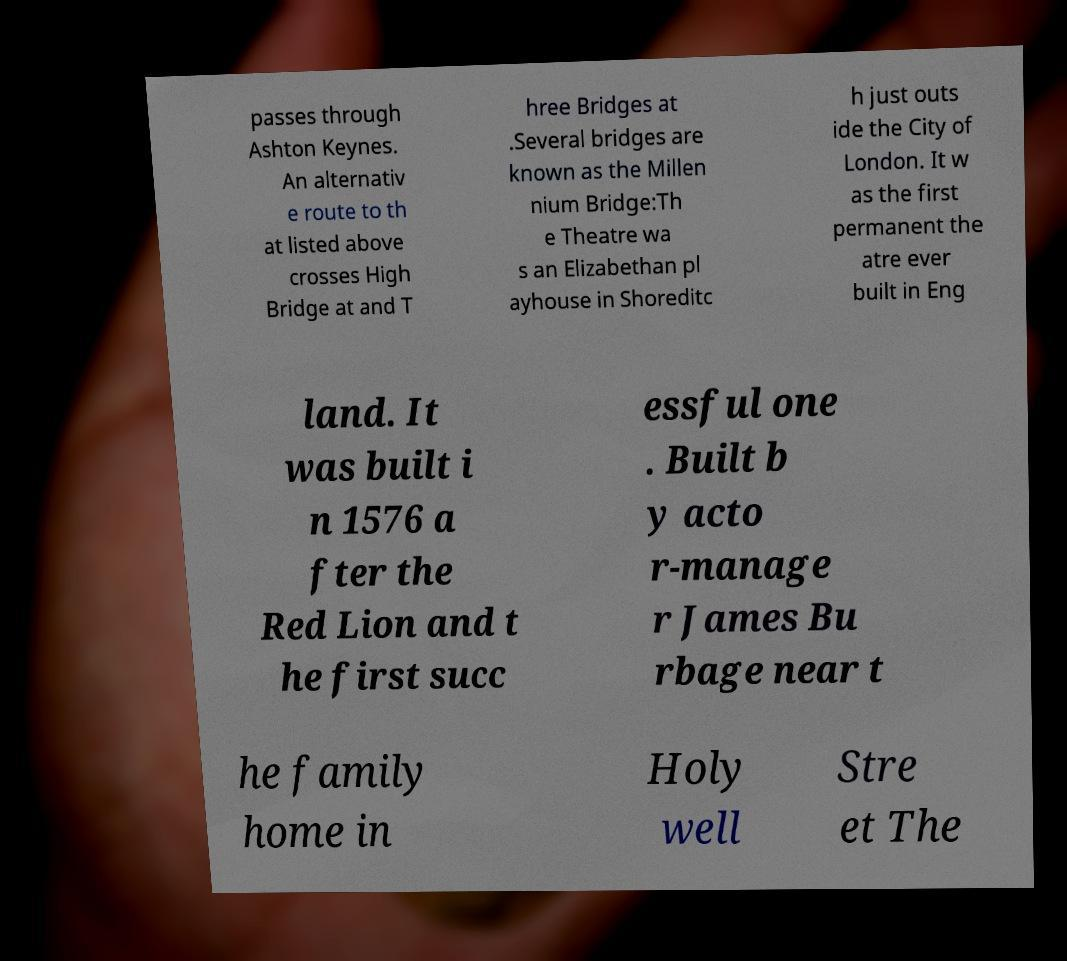Please read and relay the text visible in this image. What does it say? passes through Ashton Keynes. An alternativ e route to th at listed above crosses High Bridge at and T hree Bridges at .Several bridges are known as the Millen nium Bridge:Th e Theatre wa s an Elizabethan pl ayhouse in Shoreditc h just outs ide the City of London. It w as the first permanent the atre ever built in Eng land. It was built i n 1576 a fter the Red Lion and t he first succ essful one . Built b y acto r-manage r James Bu rbage near t he family home in Holy well Stre et The 